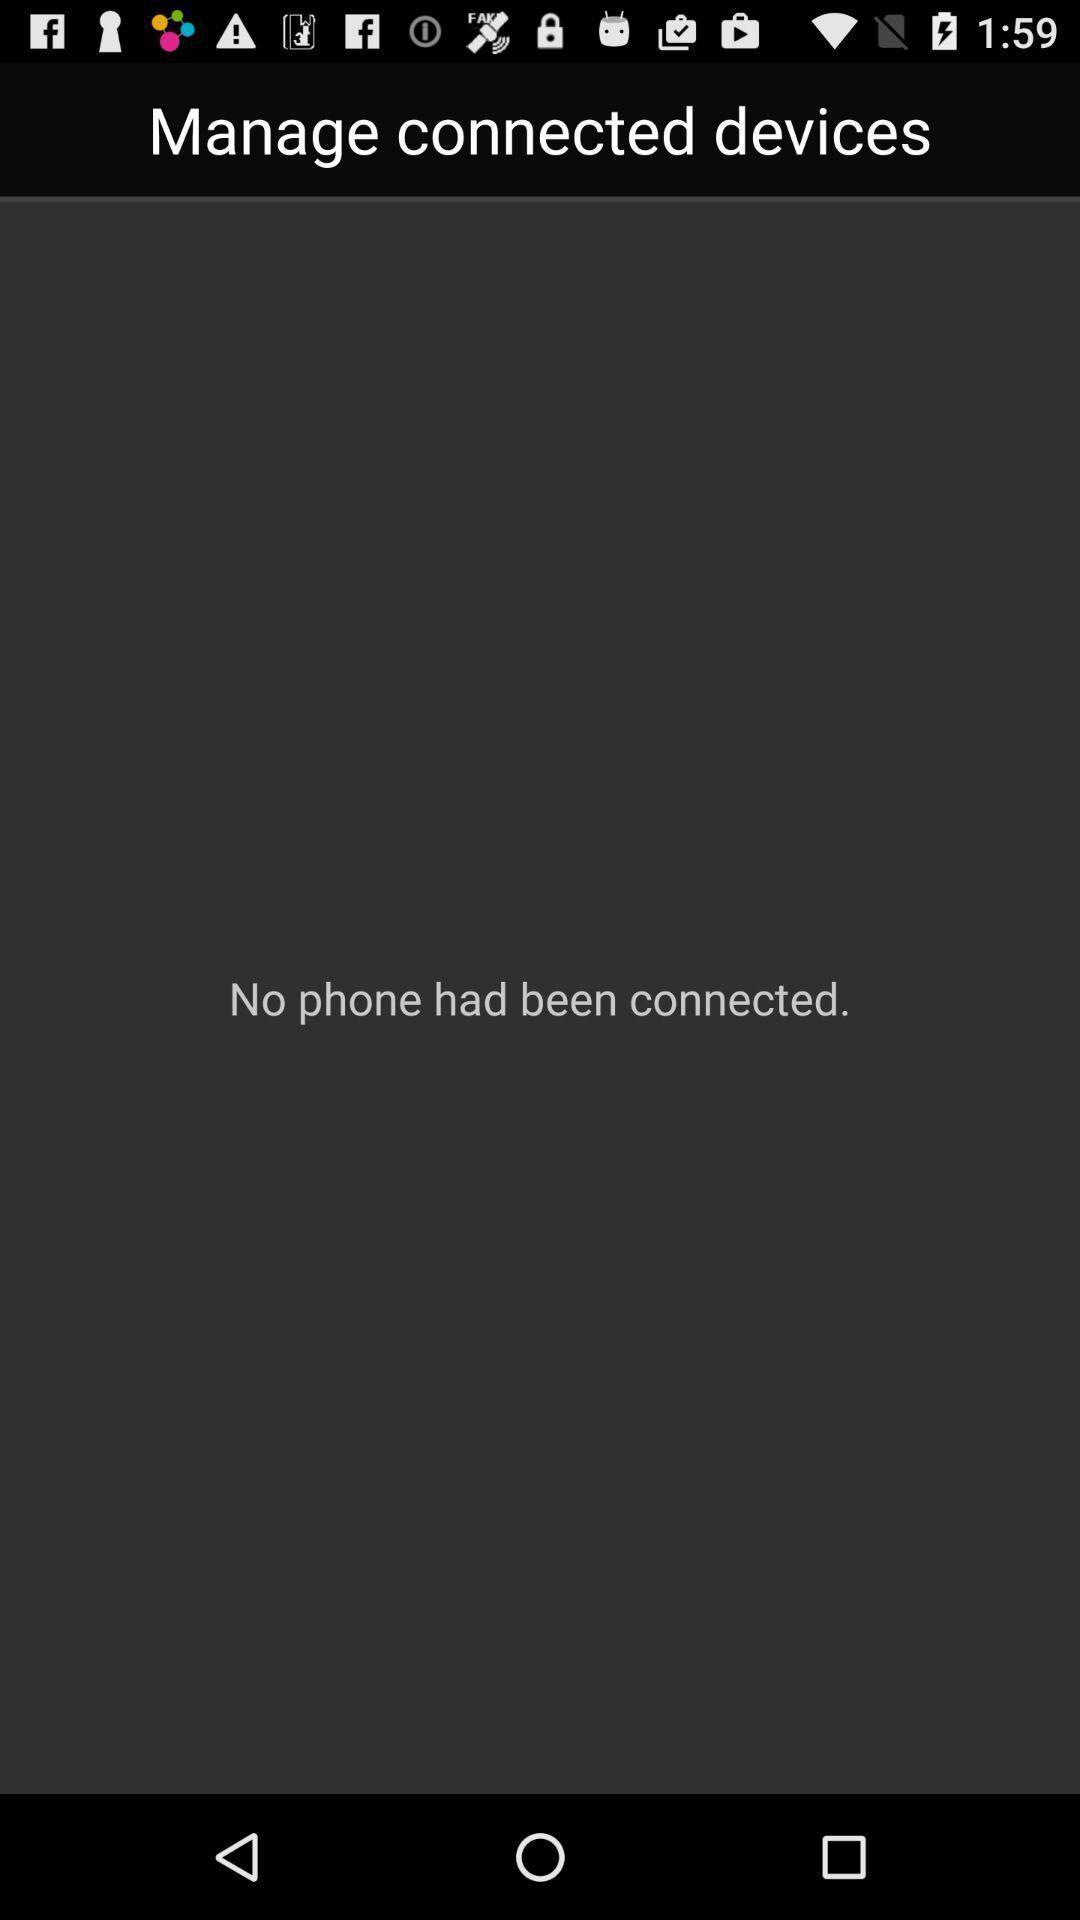Explain what's happening in this screen capture. Page to manage connected devices. 